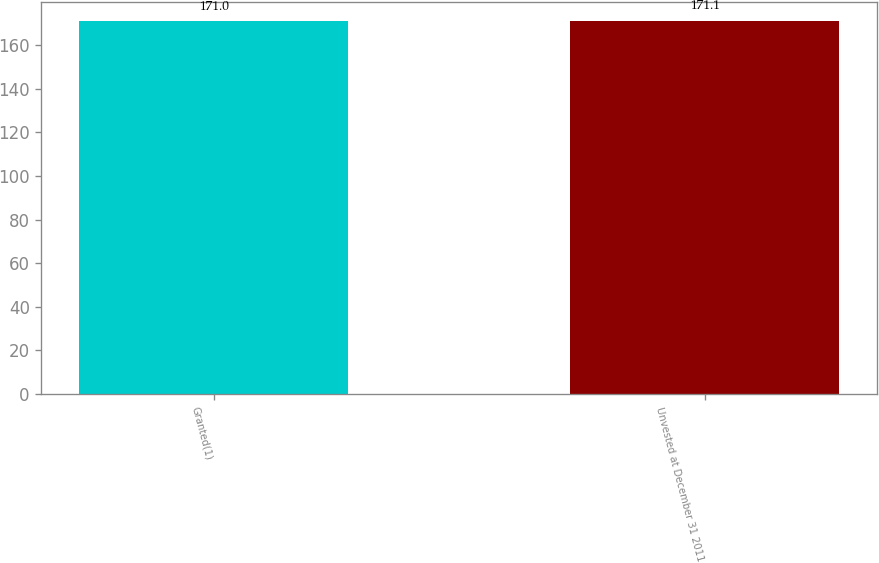Convert chart to OTSL. <chart><loc_0><loc_0><loc_500><loc_500><bar_chart><fcel>Granted(1)<fcel>Unvested at December 31 2011<nl><fcel>171<fcel>171.1<nl></chart> 